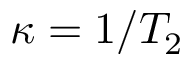<formula> <loc_0><loc_0><loc_500><loc_500>\kappa = 1 / T _ { 2 }</formula> 